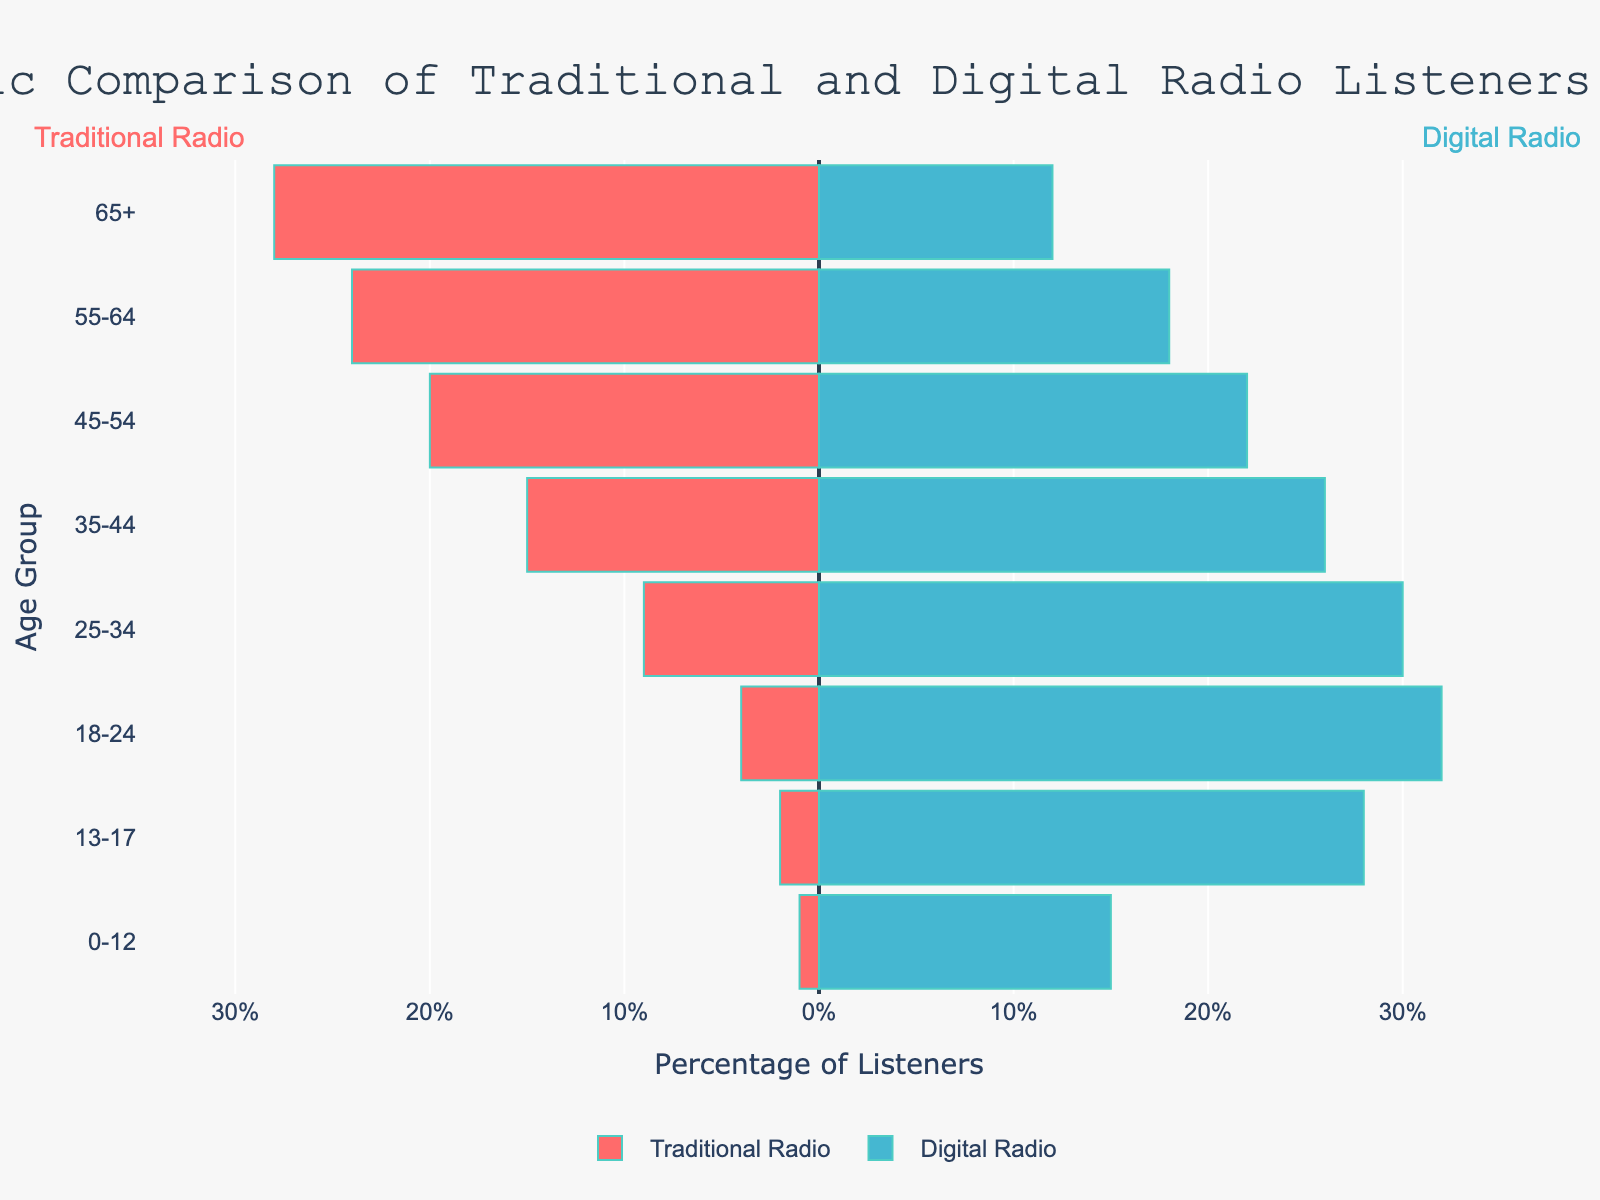What is the title of the figure? The title of the figure is usually located at the top center of the plot. In this case, the title is "Demographic Comparison of Traditional and Digital Radio Listeners in the UK".
Answer: Demographic Comparison of Traditional and Digital Radio Listeners in the UK Which color represents traditional radio listeners? The bars representing traditional radio listeners are colored red. This information is also confirmed by the legend below the chart.
Answer: Red How many age groups are there in the plot? The age groups are listed along the y-axis, and by counting them, we find there are 8 distinct age groups: 0-12, 13-17, 18-24, 25-34, 35-44, 45-54, 55-64, and 65+.
Answer: 8 Which age group has the highest percentage of digital radio listeners? By looking at the lengths of the blue bars (digital radio listeners), we see that the age group 18-24 has the longest bar, indicating the highest percentage.
Answer: 18-24 What is the difference in percentage between traditional and digital radio listeners for the age group 25-34? In the age group 25-34, traditional radio listeners account for 9%, and digital radio listeners account for 30%. The difference is
Answer: 21% Which age group shows the smallest gap between traditional and digital radio listeners? The age group 45-54 shows 20% for traditional and 22% for digital, resulting in a gap of 2%. This is the smallest gap among all age groups.
Answer: 45-54 Is there any age group where traditional radio listeners outnumber digital radio listeners? By looking at the bars, we see that for the age groups 65+ (28% traditional vs. 12% digital) and 55-64 (24% traditional vs. 18% digital), traditional radio listeners outnumber digital radio listeners.
Answer: Yes, 65+ and 55-64 For the age group 0-12, how much larger is the percentage of digital radio listeners compared to traditional radio listeners? For the age group 0-12, digital radio listeners are 15%, and traditional radio listeners are 1%. The percentage difference is
Answer: 14% What is the total percentage of traditional radio listeners across all age groups? Adding the percentages for traditional radio listeners across all age groups: 1 + 2 + 4 + 9 + 15 + 20 + 24 + 28 = 103%.
Answer: 103% Which age group has a higher percentage of digital radio listeners compared to traditional radio listeners in the age group 35-44? For the age group 35-44, the digital radio percentage is 26%. Age groups 18-24 (32%) and 25-34 (30%) have higher percentages.
Answer: 18-24, 25-34 